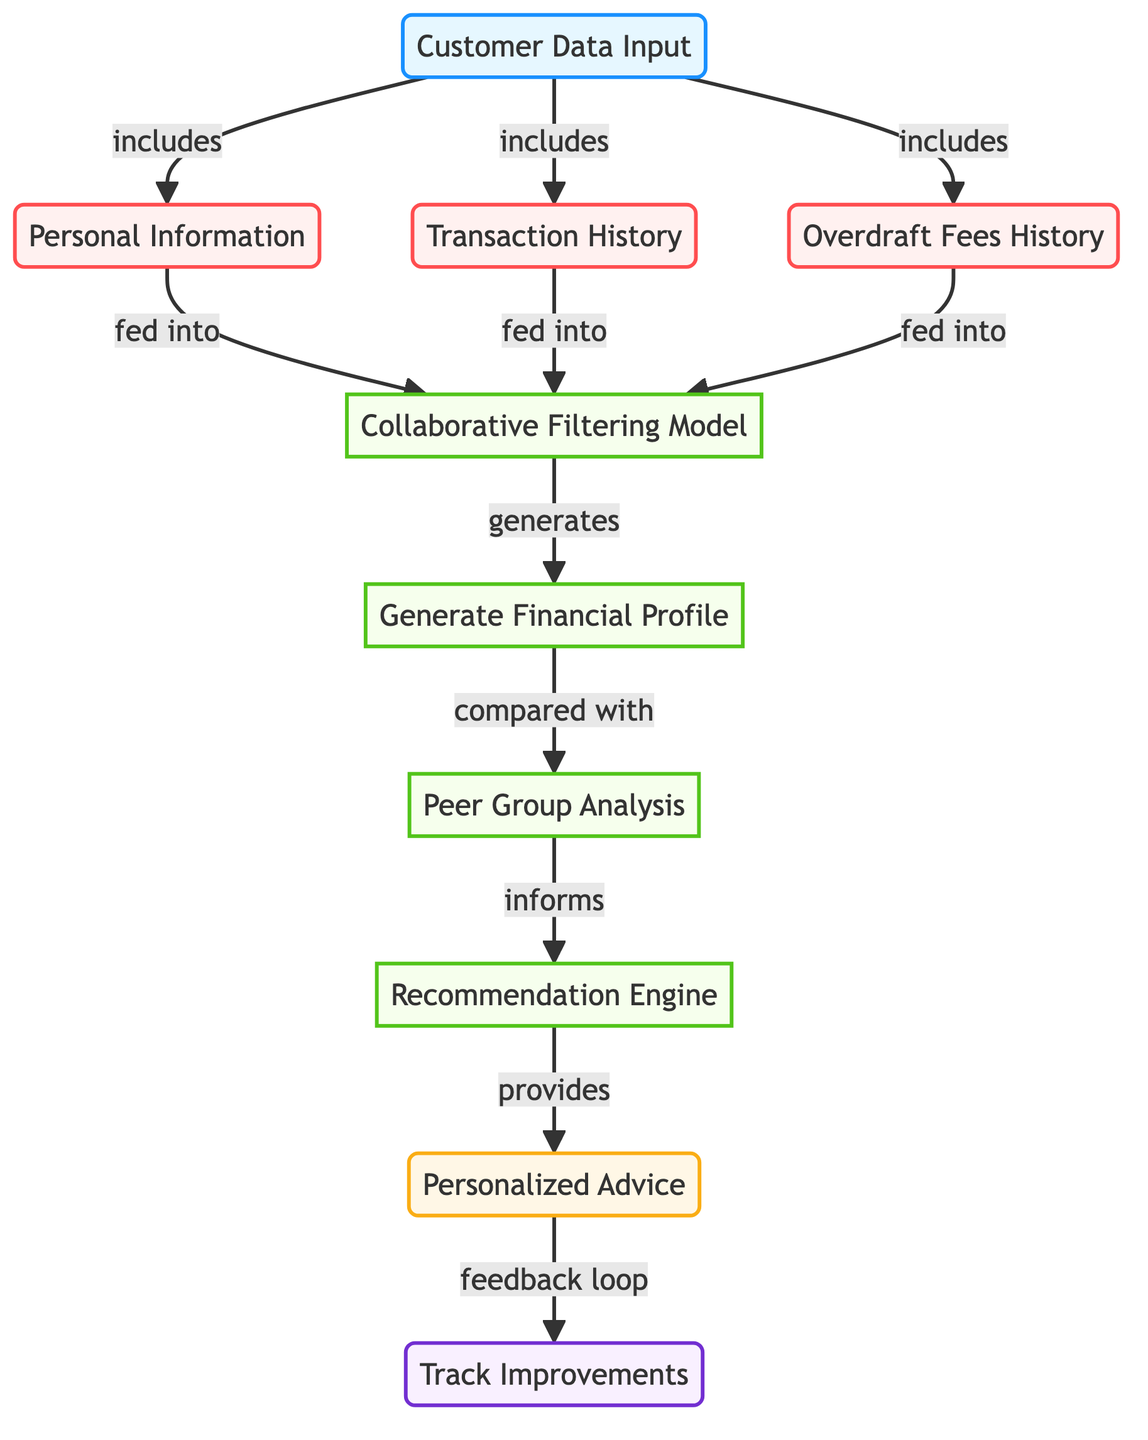What is the first node in the diagram? The first node in the flowchart is labeled "Customer Data Input," which is where the process starts by gathering data from the customer.
Answer: Customer Data Input How many types of data are included in customer data input? The "Customer Data Input" node is connected to three distinct types of data: personal information, transaction history, and overdraft fees history. Thus, there are three types of data.
Answer: 3 What type of model is used after customer data input? After the customer data input, the data flows into a "Collaborative Filtering Model," where the information is processed to create recommendations.
Answer: Collaborative Filtering Model What does the "Recommendation Engine" provide? The "Recommendation Engine" generates "Personalized Advice" based on the analysis of the financial profile and peer group analysis performed previously in the flowchart.
Answer: Personalized Advice How does the process track improvements? The process tracks improvements through a feedback loop originating from the "Personalized Advice" node to the "Track Improvements" node, indicating that feedback is used to understand effectiveness and changes over time.
Answer: Track Improvements What nodes directly feed into the collaborative filtering model? The nodes that feed into the "Collaborative Filtering Model" include personal information, transaction history, and overdraft fees history, which are directly linked to it based on the diagram’s structure.
Answer: Personal Information, Transaction History, Overdraft Fees History In what stage is the financial profile generated? The financial profile is generated after the collaborative filtering model processes the customer data input, indicating that this happens during the processing stage immediately following model application.
Answer: Generate Financial Profile What informs the recommendation engine? The recommendation engine is informed by the peer group analysis conducted after generating the financial profile, showing that this stage uses comparative data for effective recommendations.
Answer: Peer Group Analysis 